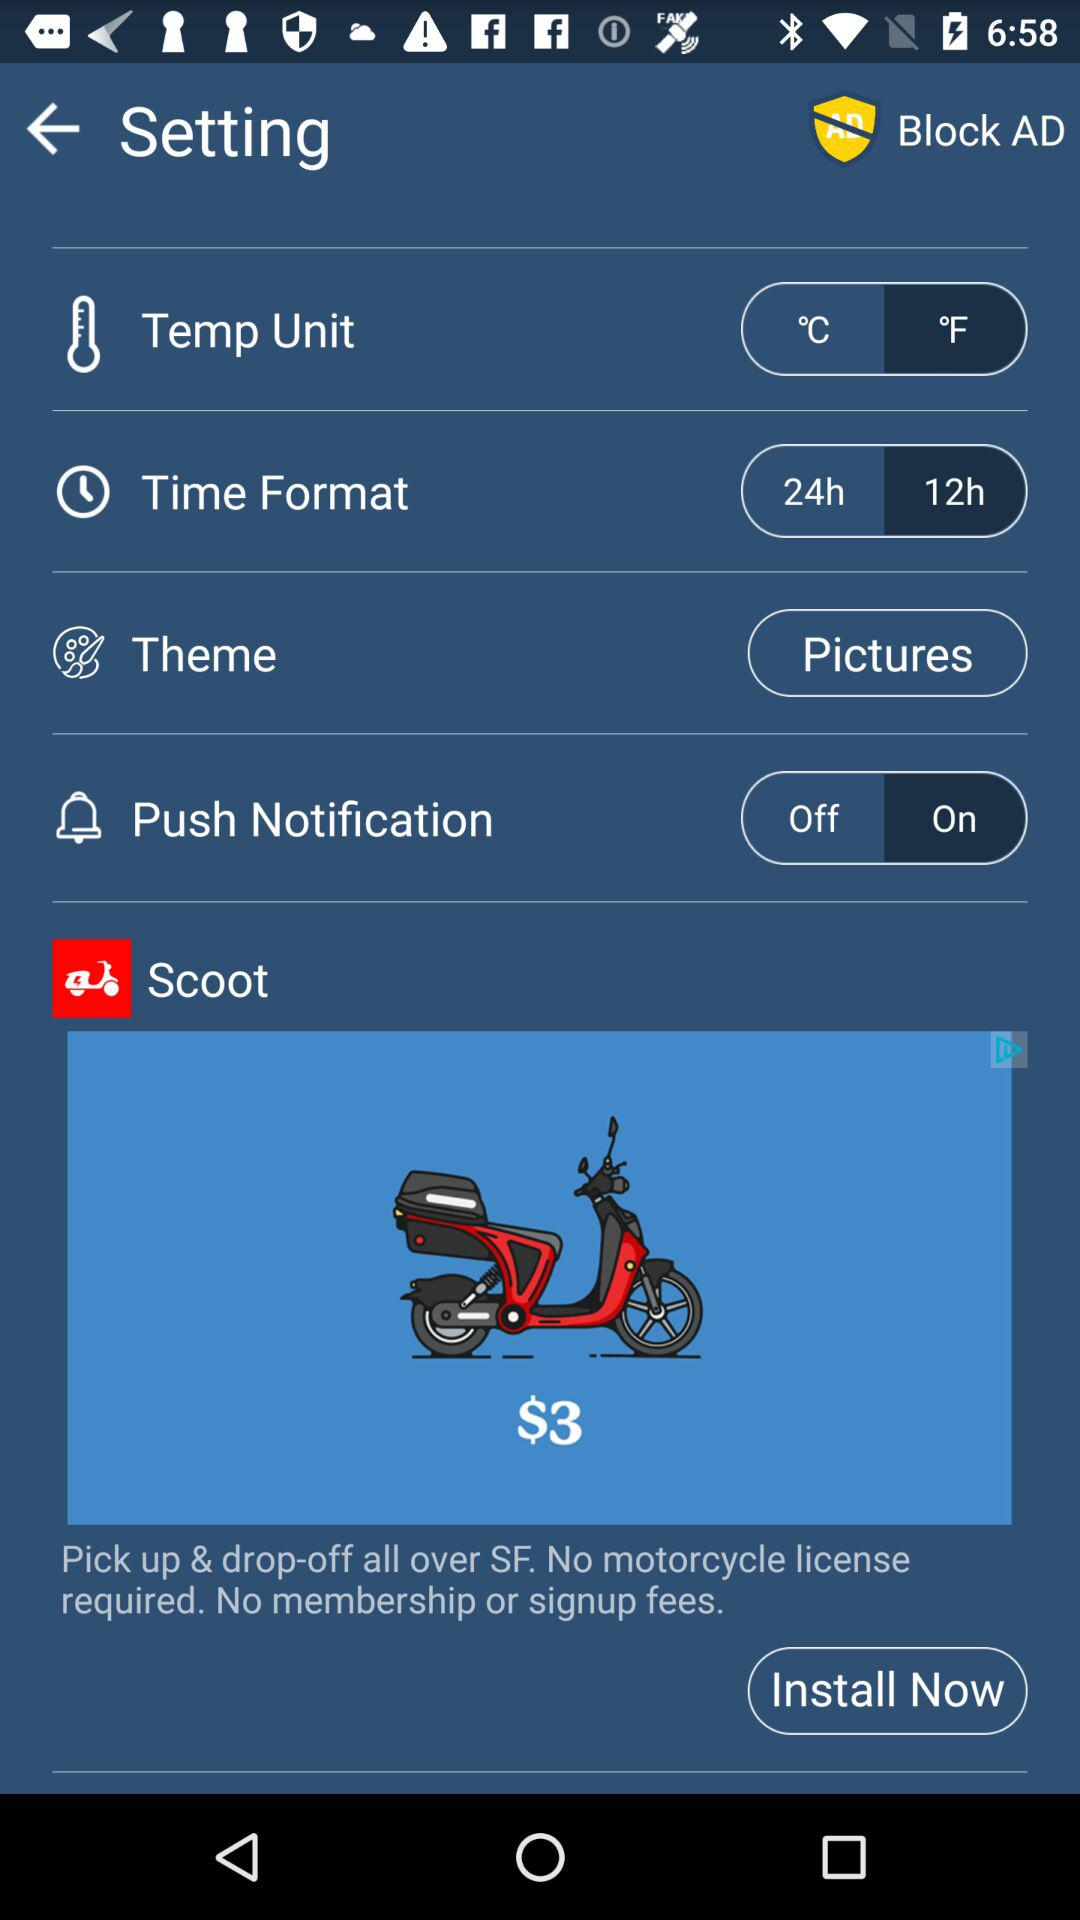Which theme is selected? The selected theme is "Pictures". 